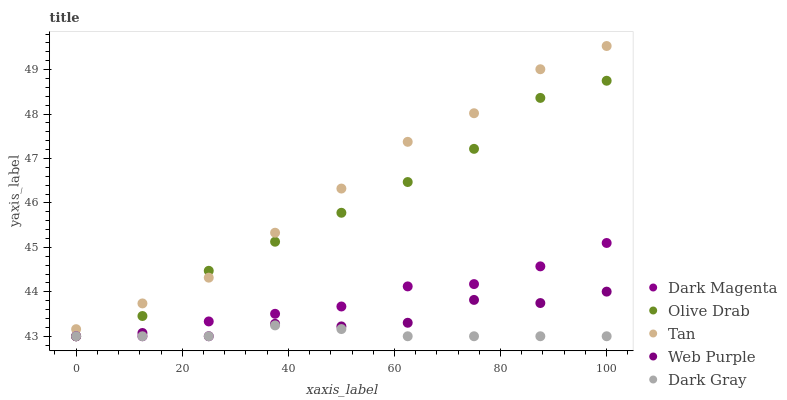Does Dark Gray have the minimum area under the curve?
Answer yes or no. Yes. Does Tan have the maximum area under the curve?
Answer yes or no. Yes. Does Web Purple have the minimum area under the curve?
Answer yes or no. No. Does Web Purple have the maximum area under the curve?
Answer yes or no. No. Is Dark Gray the smoothest?
Answer yes or no. Yes. Is Web Purple the roughest?
Answer yes or no. Yes. Is Tan the smoothest?
Answer yes or no. No. Is Tan the roughest?
Answer yes or no. No. Does Dark Gray have the lowest value?
Answer yes or no. Yes. Does Tan have the lowest value?
Answer yes or no. No. Does Tan have the highest value?
Answer yes or no. Yes. Does Web Purple have the highest value?
Answer yes or no. No. Is Dark Gray less than Tan?
Answer yes or no. Yes. Is Tan greater than Web Purple?
Answer yes or no. Yes. Does Dark Magenta intersect Dark Gray?
Answer yes or no. Yes. Is Dark Magenta less than Dark Gray?
Answer yes or no. No. Is Dark Magenta greater than Dark Gray?
Answer yes or no. No. Does Dark Gray intersect Tan?
Answer yes or no. No. 